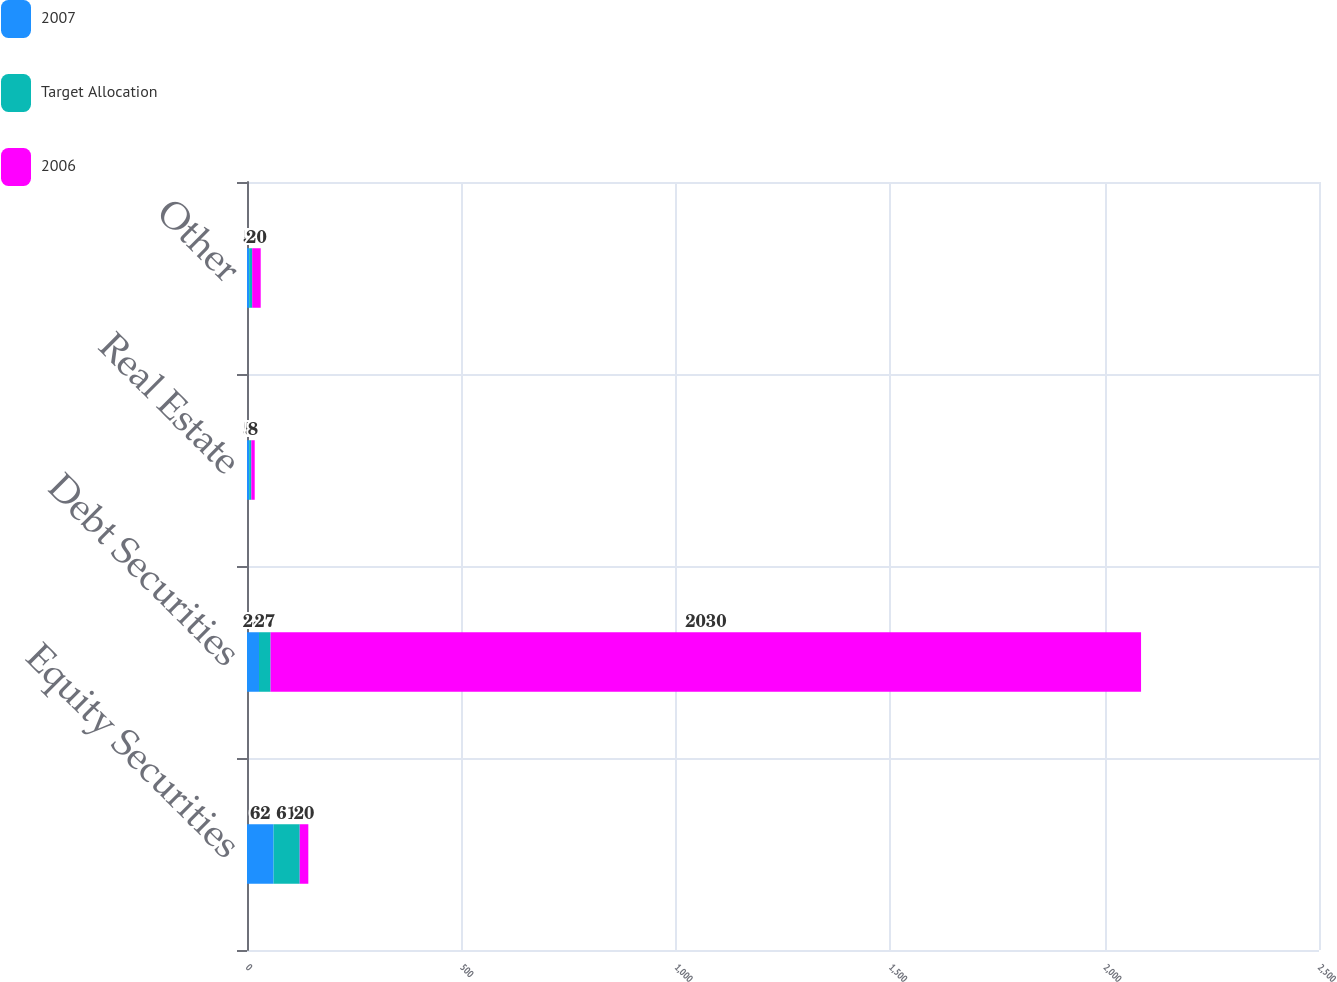Convert chart to OTSL. <chart><loc_0><loc_0><loc_500><loc_500><stacked_bar_chart><ecel><fcel>Equity Securities<fcel>Debt Securities<fcel>Real Estate<fcel>Other<nl><fcel>2007<fcel>62<fcel>28<fcel>5<fcel>5<nl><fcel>Target Allocation<fcel>61<fcel>27<fcel>5<fcel>7<nl><fcel>2006<fcel>20<fcel>2030<fcel>8<fcel>20<nl></chart> 